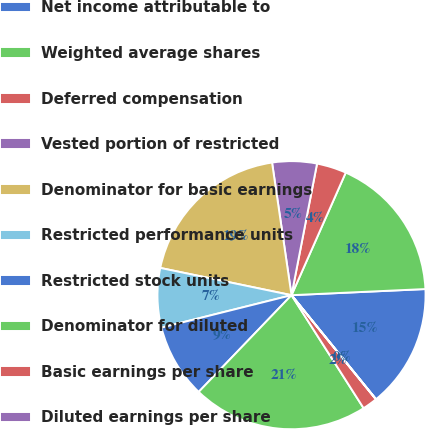Convert chart to OTSL. <chart><loc_0><loc_0><loc_500><loc_500><pie_chart><fcel>Net income attributable to<fcel>Weighted average shares<fcel>Deferred compensation<fcel>Vested portion of restricted<fcel>Denominator for basic earnings<fcel>Restricted performance units<fcel>Restricted stock units<fcel>Denominator for diluted<fcel>Basic earnings per share<fcel>Diluted earnings per share<nl><fcel>14.87%<fcel>17.64%<fcel>3.58%<fcel>5.37%<fcel>19.42%<fcel>7.15%<fcel>8.94%<fcel>21.21%<fcel>1.8%<fcel>0.02%<nl></chart> 